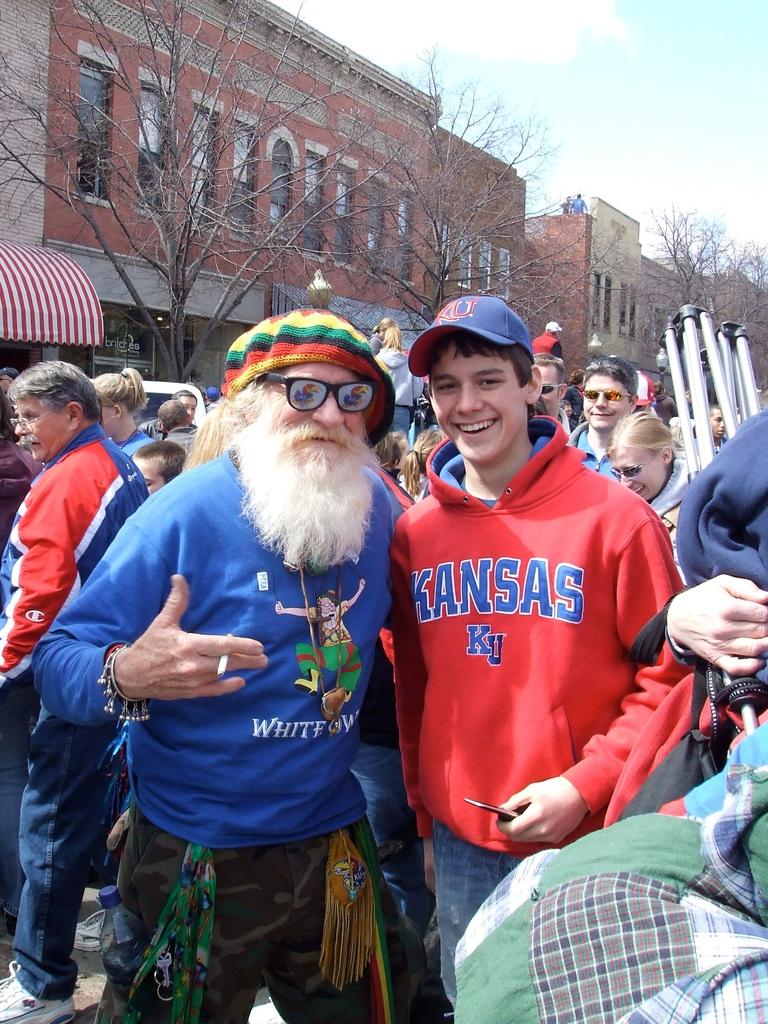What are the people in the image doing? The people in the image are standing on the road. What can be seen in the background of the image? There are buildings, stores, and trees in the background. Are there any people on the buildings? Yes, there are persons standing on the buildings. What is the condition of the sky in the image? The sky is visible with clouds in the image. Can you see a squirrel climbing the mountain in the image? There is no mountain or squirrel present in the image. How many steps are there on the buildings in the image? The image does not provide information about the number of steps on the buildings. 